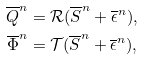<formula> <loc_0><loc_0><loc_500><loc_500>\overline { Q } ^ { n } & = \mathcal { R } ( \overline { S } ^ { n } + \overline { \epsilon } ^ { n } ) , \\ \overline { \Phi } ^ { n } & = \mathcal { T } ( \overline { S } ^ { n } + \overline { \epsilon } ^ { n } ) ,</formula> 